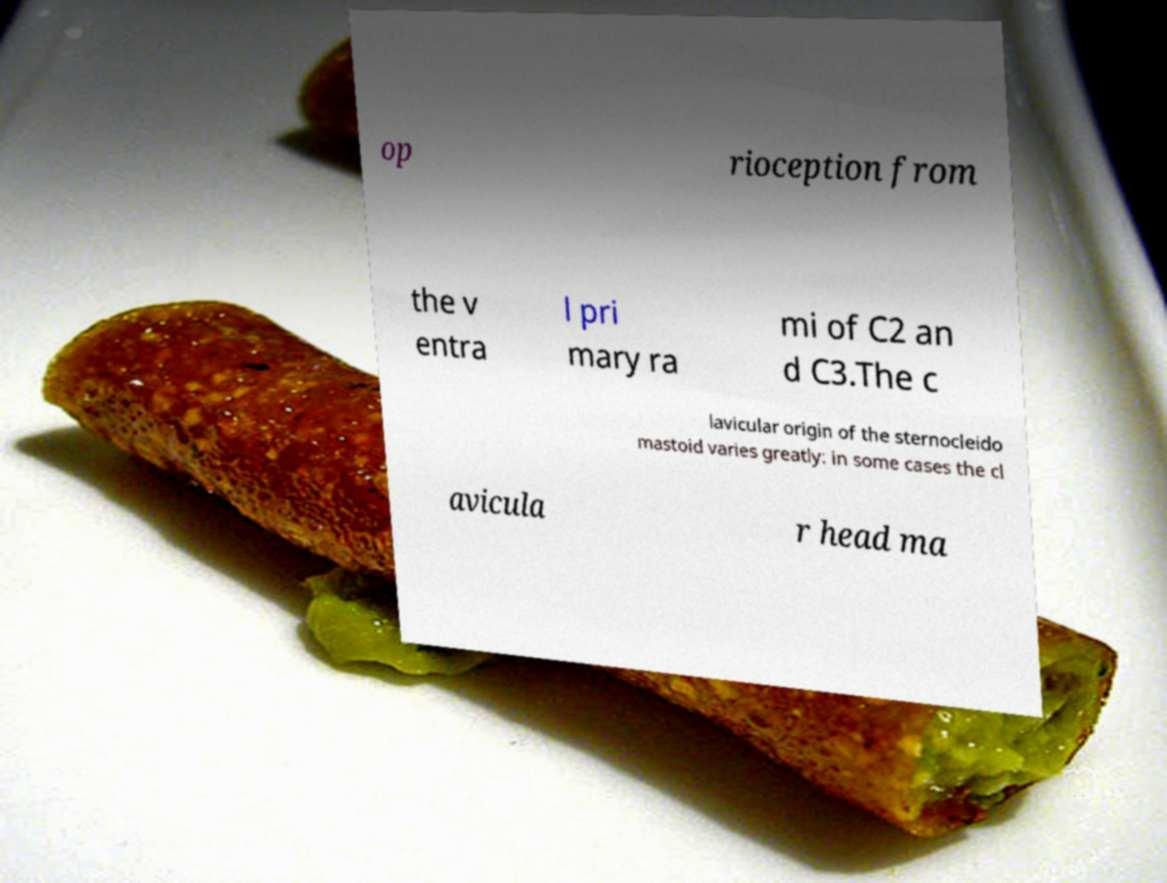For documentation purposes, I need the text within this image transcribed. Could you provide that? op rioception from the v entra l pri mary ra mi of C2 an d C3.The c lavicular origin of the sternocleido mastoid varies greatly: in some cases the cl avicula r head ma 